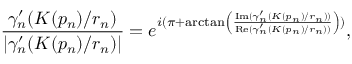<formula> <loc_0><loc_0><loc_500><loc_500>\frac { \gamma _ { n } ^ { \prime } ( K ( p _ { n } ) / r _ { n } ) } { | \gamma _ { n } ^ { \prime } ( K ( p _ { n } ) / r _ { n } ) | } = e ^ { i ( \pi + \arctan \left ( \frac { I m ( \gamma _ { n } ^ { \prime } ( K ( p _ { n } ) / r _ { n } ) ) } { R e ( \gamma _ { n } ^ { \prime } ( K ( p _ { n } ) / r _ { n } ) ) } \right ) ) } ,</formula> 